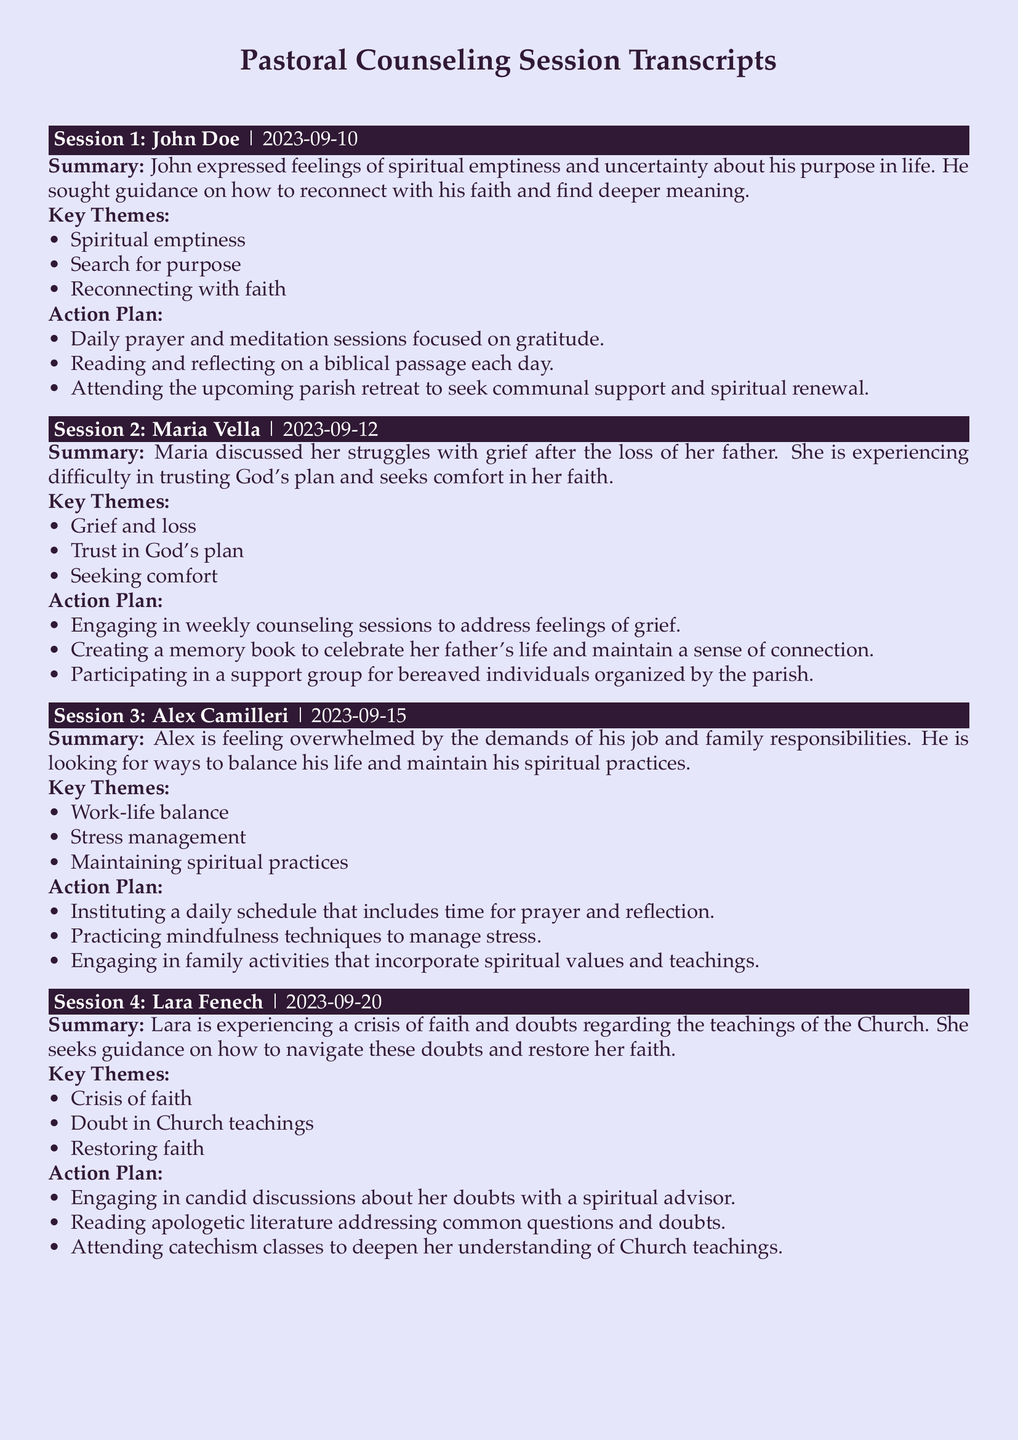What is the date of Session 2? The date of each session is provided directly under the session header, indicating the date when it took place.
Answer: 2023-09-12 Who is the participant in Session 4? Each session includes the name of the participant at the beginning of the summary, identifying who sought guidance.
Answer: Lara Fenech What is one key theme discussed in Session 1? Each session lists key themes that were discussed, which highlight the main concerns or issues addressed during that session.
Answer: Spiritual emptiness How many action items are listed for Alex Camilleri? The action plan section outlines specific steps that the participant agreed to follow, directly reflecting their personalized action items.
Answer: 3 What type of support is Maria seeking after her father's loss? The document summarizes participants' feelings and what they seek, specifically reflecting their emotional or spiritual needs.
Answer: Comfort What crisis is Lara experiencing? Each summary identifies the main issues participants are facing, reflecting their state of mind or spiritual struggles.
Answer: Crisis of faith What practice is suggested for Alex to manage stress? Each action plan specifies recommendations or practices that participants can incorporate into their lives to address their concerns.
Answer: Mindfulness techniques How many sessions discussed grief and loss? By reviewing the summaries, one can identify the topics covered and count how many sessions dealt with specific issues.
Answer: 1 